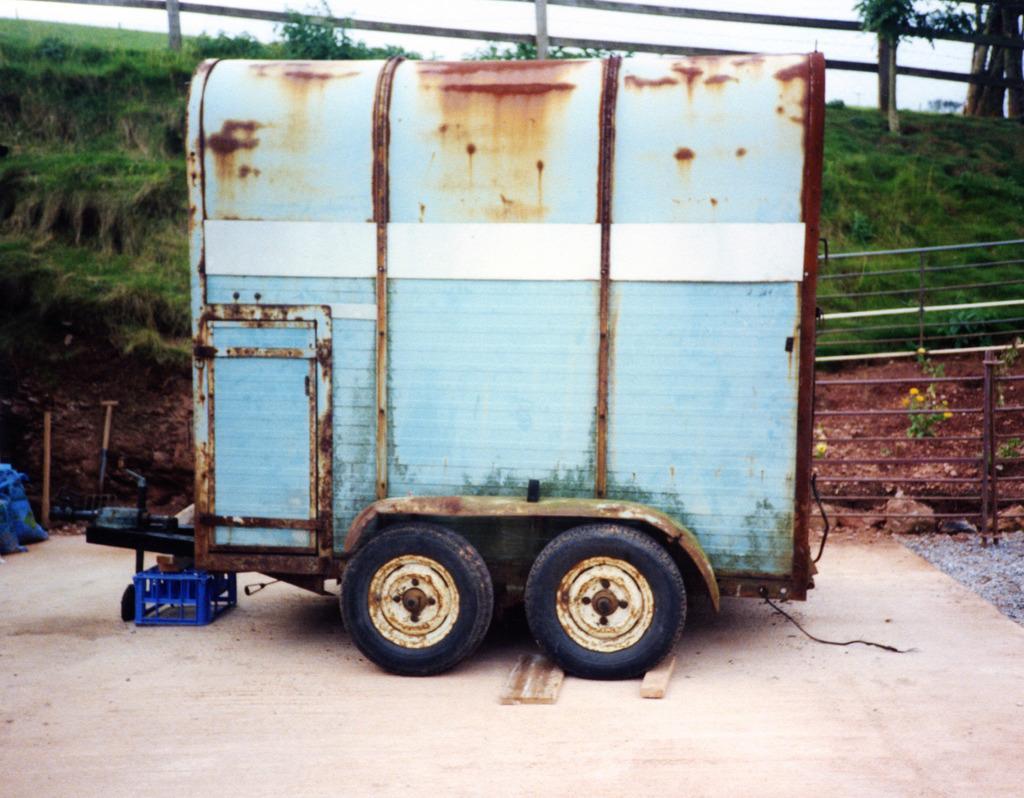How would you summarize this image in a sentence or two? In this image at front there is a vehicle. At the background there is grass on the surface. 